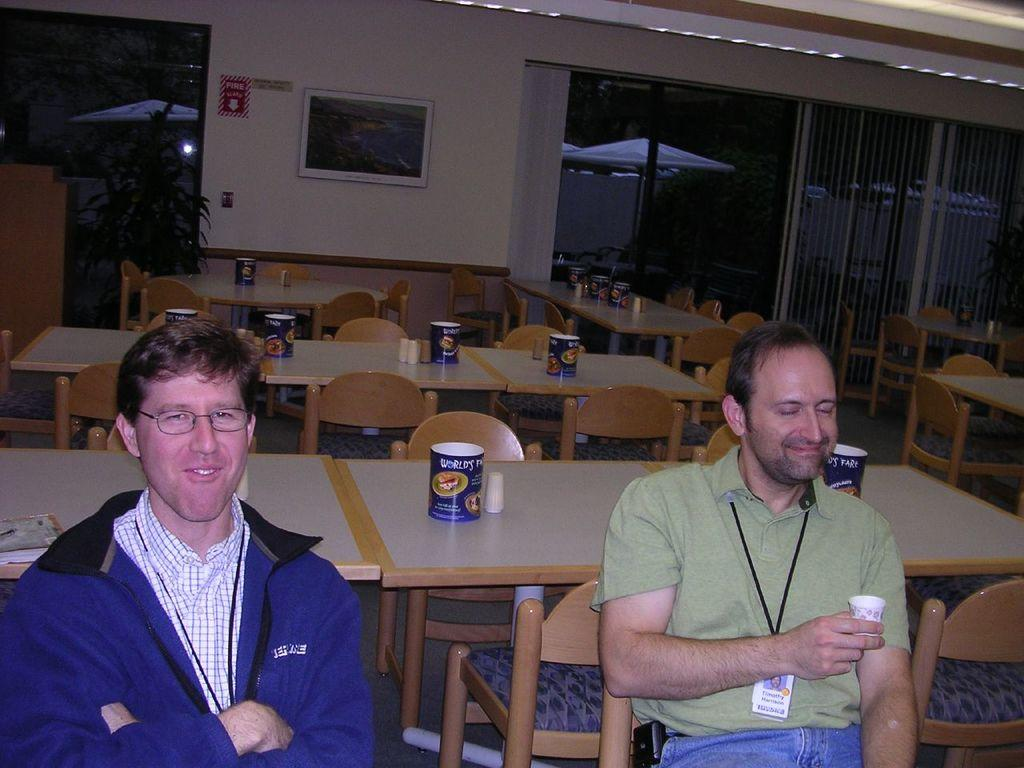How many people are in the image? There are two men in the image. What are the men doing in the image? The men are sitting in chairs. What is the facial expression of the men in the image? The men are smiling. What can be seen in the background of the image? Tables and chairs are visible behind the men. What type of plantation is visible in the image? There is no plantation present in the image. What suggestion can be made to improve the seating arrangement in the image? The conversation does not involve making suggestions or improvements to the image. 